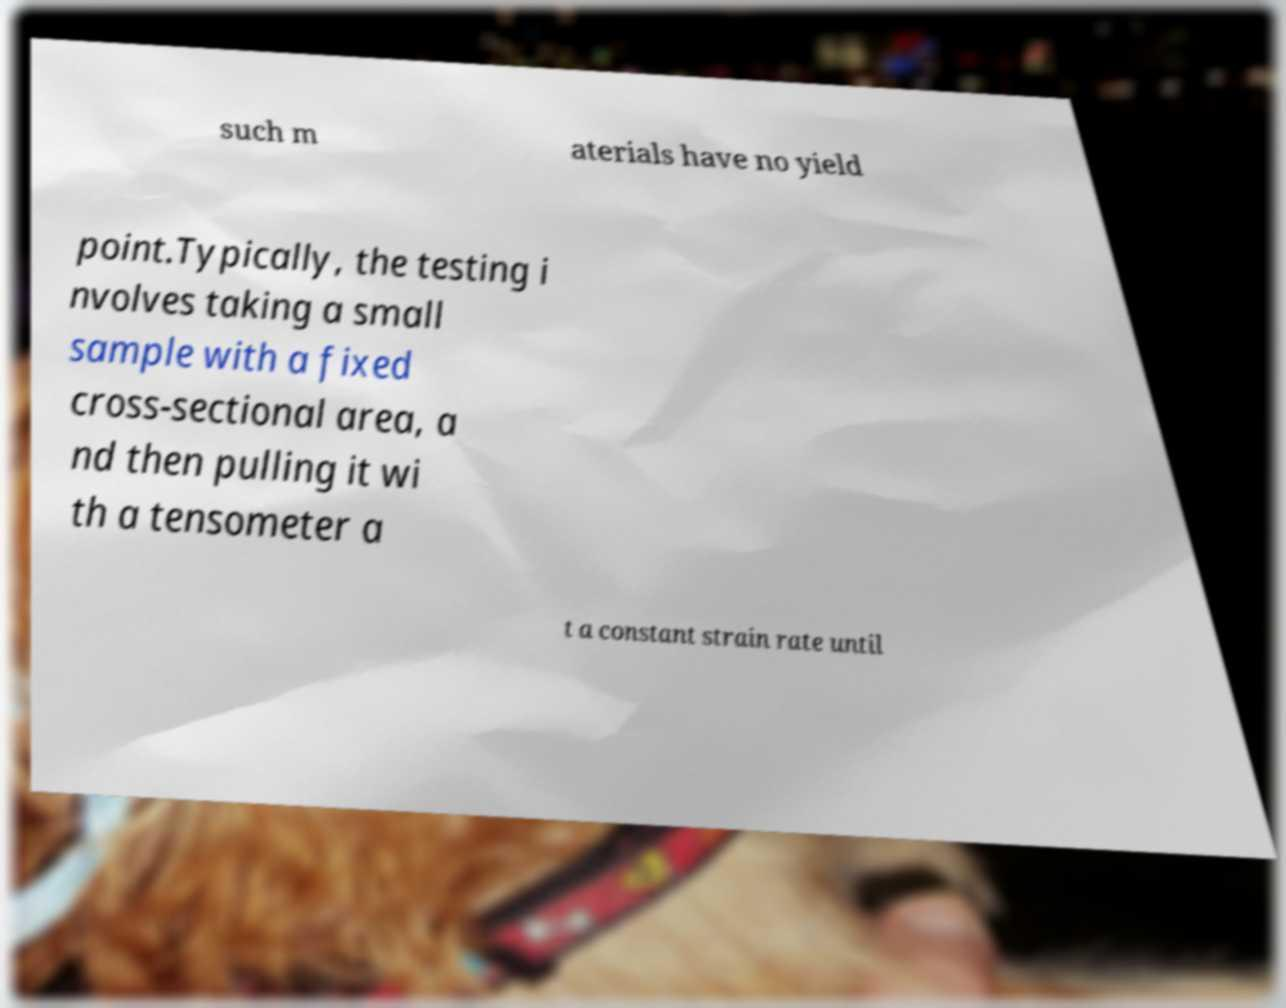There's text embedded in this image that I need extracted. Can you transcribe it verbatim? such m aterials have no yield point.Typically, the testing i nvolves taking a small sample with a fixed cross-sectional area, a nd then pulling it wi th a tensometer a t a constant strain rate until 